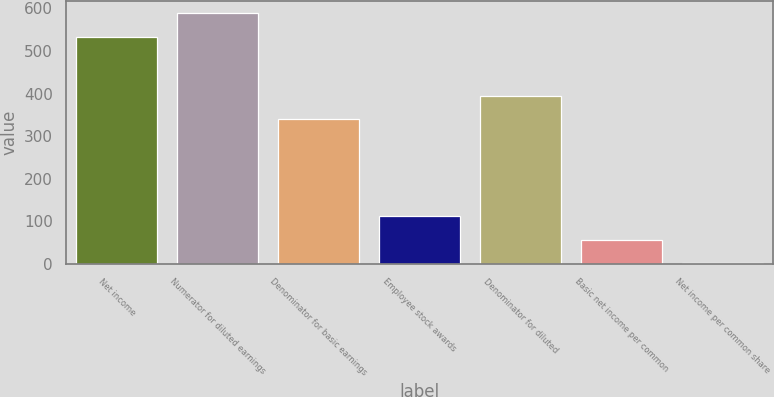Convert chart to OTSL. <chart><loc_0><loc_0><loc_500><loc_500><bar_chart><fcel>Net income<fcel>Numerator for diluted earnings<fcel>Denominator for basic earnings<fcel>Employee stock awards<fcel>Denominator for diluted<fcel>Basic net income per common<fcel>Net income per common share<nl><fcel>533.5<fcel>588.35<fcel>340.5<fcel>111.2<fcel>395.35<fcel>56.35<fcel>1.5<nl></chart> 